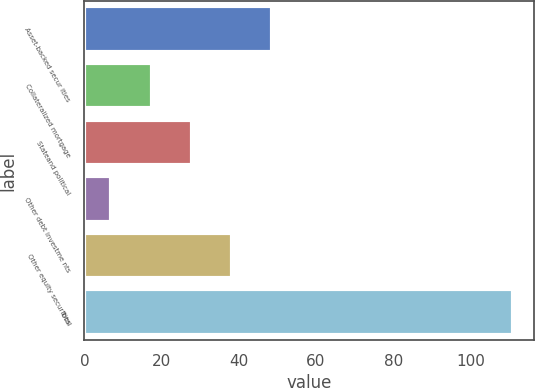Convert chart. <chart><loc_0><loc_0><loc_500><loc_500><bar_chart><fcel>Asset-backed secur ities<fcel>Collateralized mortgage<fcel>Stateand political<fcel>Other debt investme nts<fcel>Other equity securities<fcel>Total<nl><fcel>48.6<fcel>17.4<fcel>27.8<fcel>7<fcel>38.2<fcel>111<nl></chart> 